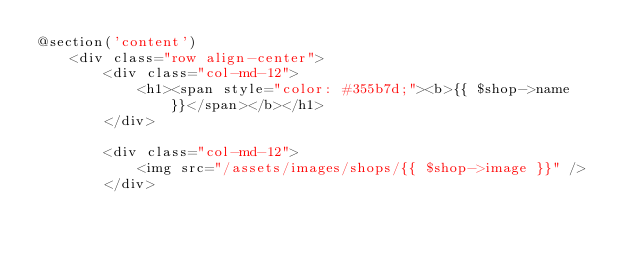<code> <loc_0><loc_0><loc_500><loc_500><_PHP_>@section('content')
    <div class="row align-center">
        <div class="col-md-12">
            <h1><span style="color: #355b7d;"><b>{{ $shop->name }}</span></b></h1>
        </div>
        
        <div class="col-md-12">
            <img src="/assets/images/shops/{{ $shop->image }}" />
        </div>
        </code> 